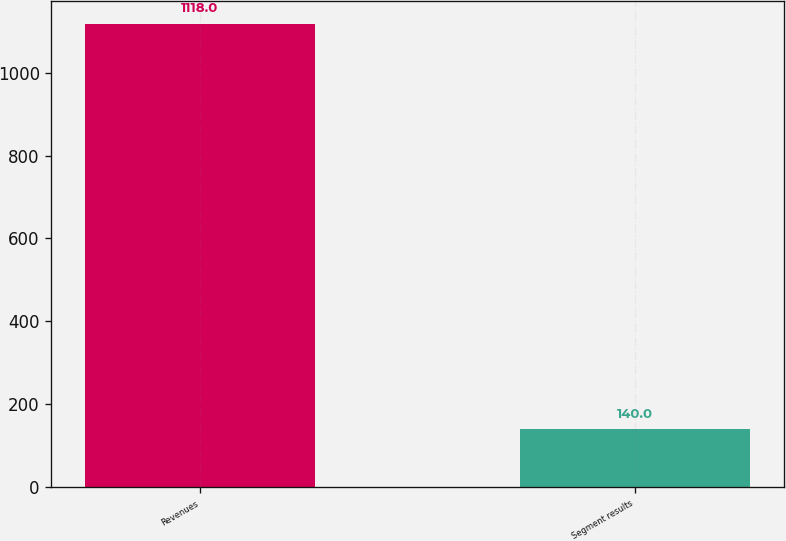<chart> <loc_0><loc_0><loc_500><loc_500><bar_chart><fcel>Revenues<fcel>Segment results<nl><fcel>1118<fcel>140<nl></chart> 